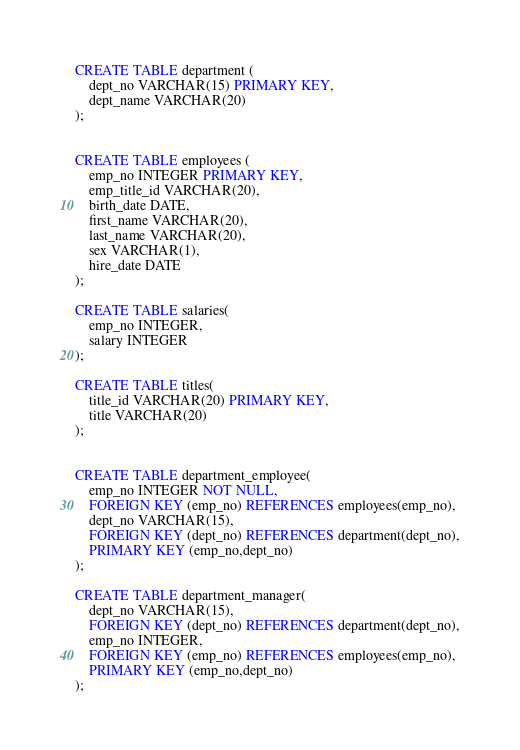Convert code to text. <code><loc_0><loc_0><loc_500><loc_500><_SQL_>CREATE TABLE department (
	dept_no VARCHAR(15) PRIMARY KEY,
	dept_name VARCHAR(20)
);

							   
CREATE TABLE employees (
	emp_no INTEGER PRIMARY KEY,
	emp_title_id VARCHAR(20),
	birth_date DATE,
	first_name VARCHAR(20),
	last_name VARCHAR(20),
	sex VARCHAR(1),
	hire_date DATE							  
);
					   
CREATE TABLE salaries(
	emp_no INTEGER,
	salary INTEGER
);
					  
CREATE TABLE titles(
	title_id VARCHAR(20) PRIMARY KEY,
	title VARCHAR(20)
);


CREATE TABLE department_employee(
	emp_no INTEGER NOT NULL,
	FOREIGN KEY (emp_no) REFERENCES employees(emp_no),
	dept_no VARCHAR(15),
	FOREIGN KEY (dept_no) REFERENCES department(dept_no),
	PRIMARY KEY (emp_no,dept_no)
);
								
CREATE TABLE department_manager(
	dept_no VARCHAR(15),
	FOREIGN KEY (dept_no) REFERENCES department(dept_no),
	emp_no INTEGER,
	FOREIGN KEY (emp_no) REFERENCES employees(emp_no),
	PRIMARY KEY (emp_no,dept_no)
);</code> 